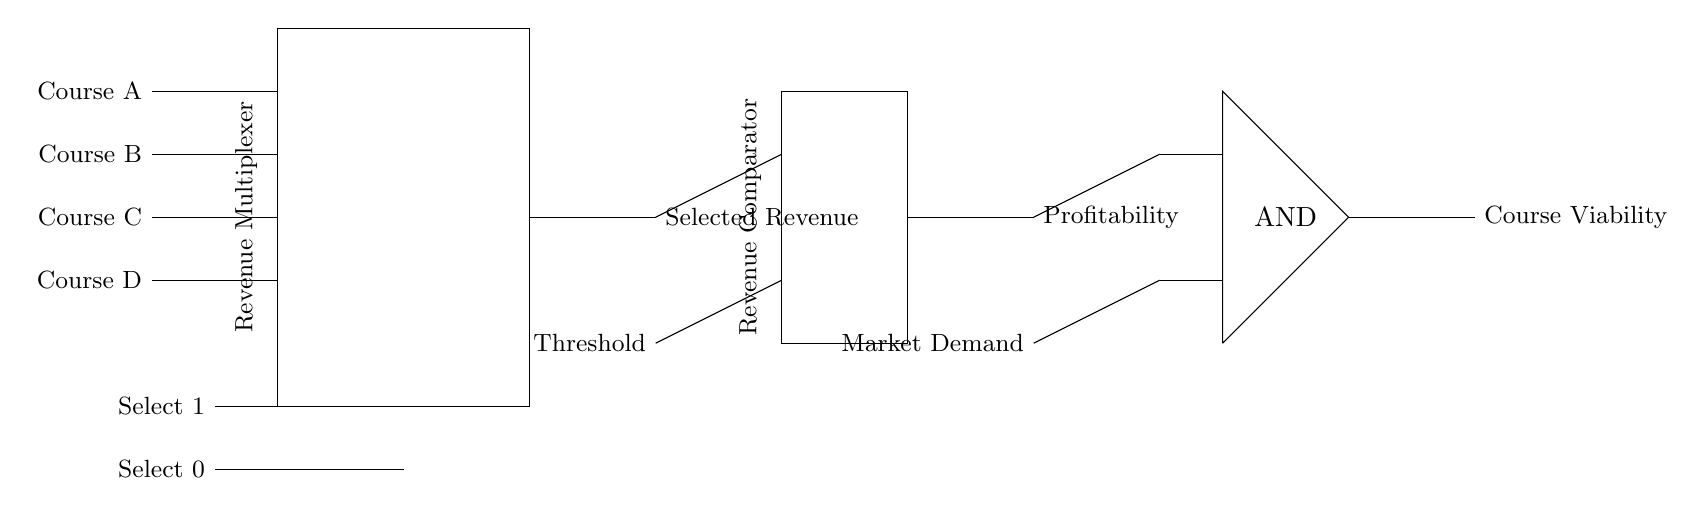What is the main function of the circuit? The main function of the circuit is to compare revenue streams for different online courses, selecting and evaluating their profitability based on market demand.
Answer: Revenue comparison How many courses are inputted into the multiplexer? There are four courses inputted into the multiplexer: Course A, Course B, Course C, and Course D.
Answer: Four What do the select lines determine? The select lines determine which course's revenue is outputted by the multiplexer to be compared with the threshold.
Answer: Selected course revenue What are the outputs of the revenue comparator? The outputs of the revenue comparator signal profitability based on the comparison of selected revenue to a threshold.
Answer: Profitability What logic operation is performed at the AND gate? The AND gate performs a logical conjunction, which means it outputs a signal for course viability only if both the profitability and market demand are positive.
Answer: AND operation What is connected to the top input of the comparator? The top input of the comparator is connected to the selected revenue output from the multiplexer.
Answer: Selected revenue What does the final output represent? The final output represents the viability of a particular online course based on profitability and market demand inputs.
Answer: Course viability 